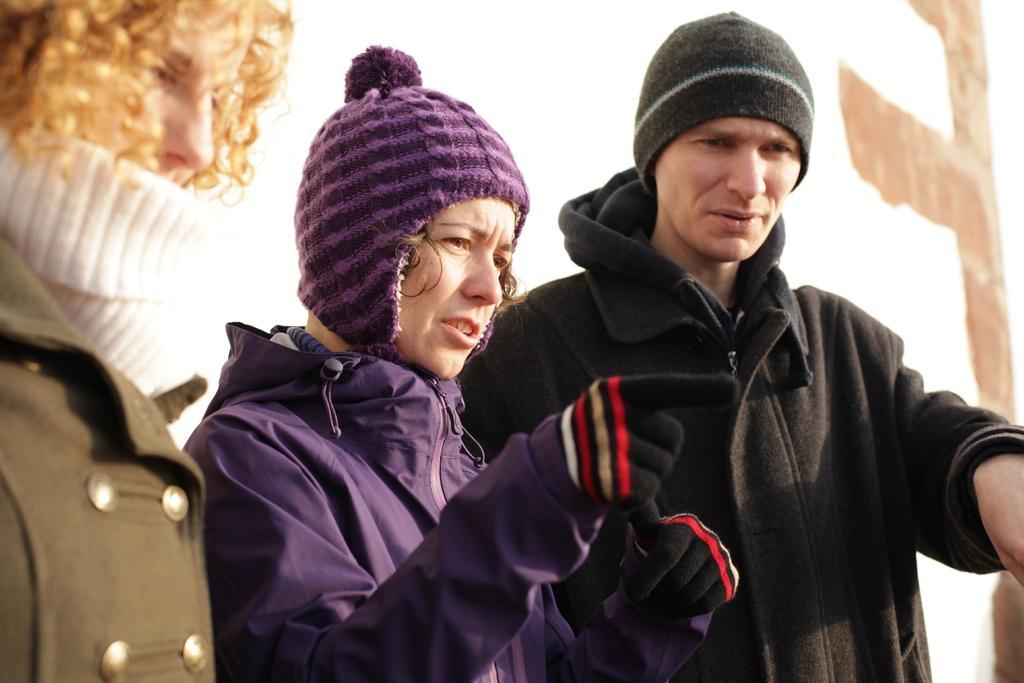Could you give a brief overview of what you see in this image? In this picture I can see the three persons, they are wearing the sweaters and caps. 